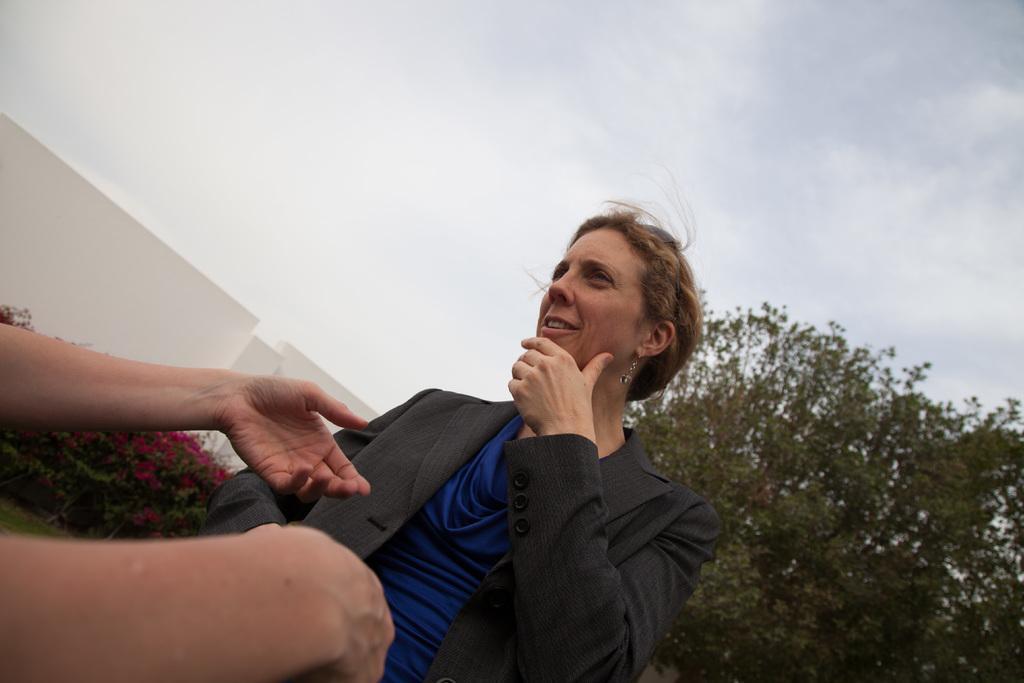Can you describe this image briefly? In this picture we can see a woman on the path and in front of the woman we can see only person hands. Behind the women there are trees, wall and a cloudy sky. 